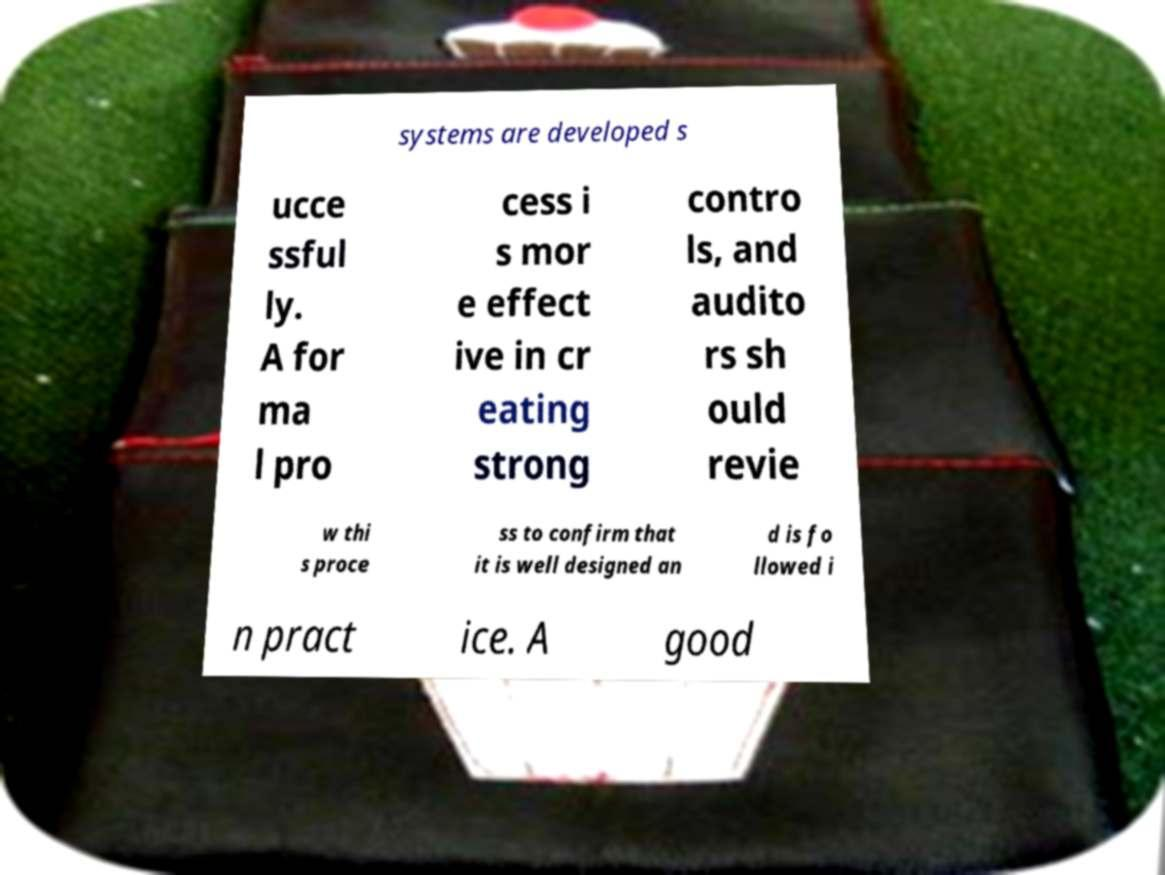Please read and relay the text visible in this image. What does it say? systems are developed s ucce ssful ly. A for ma l pro cess i s mor e effect ive in cr eating strong contro ls, and audito rs sh ould revie w thi s proce ss to confirm that it is well designed an d is fo llowed i n pract ice. A good 